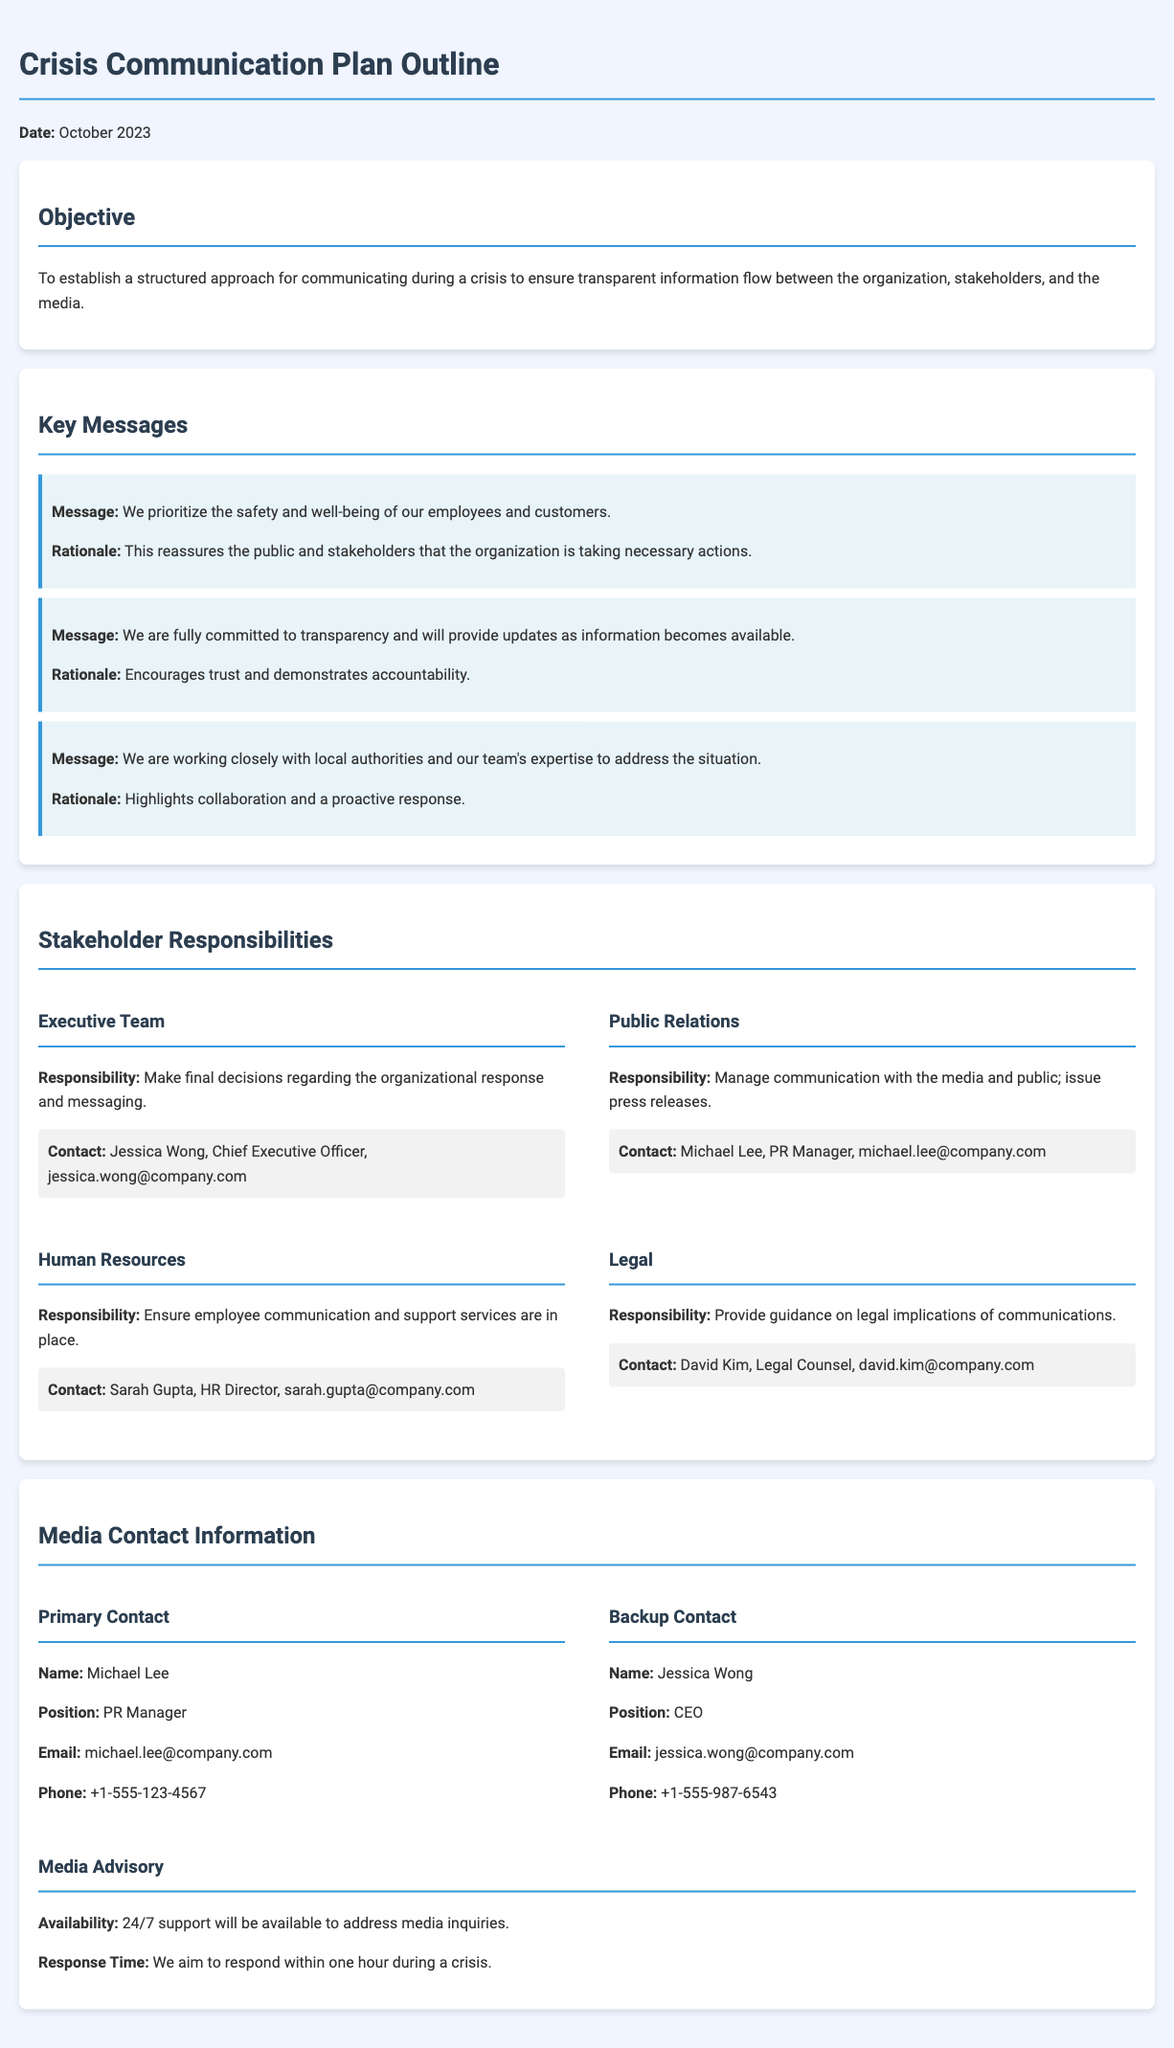What is the objective of the Crisis Communication Plan? The objective outlines the purpose of the document which is to establish a structured approach for communicating during a crisis.
Answer: To establish a structured approach for communicating during a crisis to ensure transparent information flow between the organization, stakeholders, and the media Who is responsible for managing communication with the media? This identifies the role assigned to manage interactions with the media as mentioned in the Stakeholder Responsibilities section.
Answer: Public Relations What are the key messages emphasized in the document? The key messages are significant statements that the organization wants to communicate during a crisis.
Answer: We prioritize the safety and well-being of our employees and customers; We are fully committed to transparency and will provide updates as information becomes available; We are working closely with local authorities and our team's expertise to address the situation What is the primary media contact's email address? The email address for the primary media contact is specified in the Media Contact Information section.
Answer: michael.lee@company.com How quickly does the organization aim to respond to media inquiries during a crisis? This question relates to the organization’s commitment regarding response times as detailed in the Media Advisory section.
Answer: Within one hour Who is the backup contact for media inquiries? The backup contact's information is outlined in the Media Contact Information section.
Answer: Jessica Wong What is the contact information for the HR Director? This is retrieved from the Stakeholder Responsibilities section where contact details for the HR Director are provided.
Answer: Sarah Gupta, HR Director, sarah.gupta@company.com What is the responsibility of the Executive Team? This asks for the specific duty assigned to the Executive Team as stated in the document.
Answer: Make final decisions regarding the organizational response and messaging 